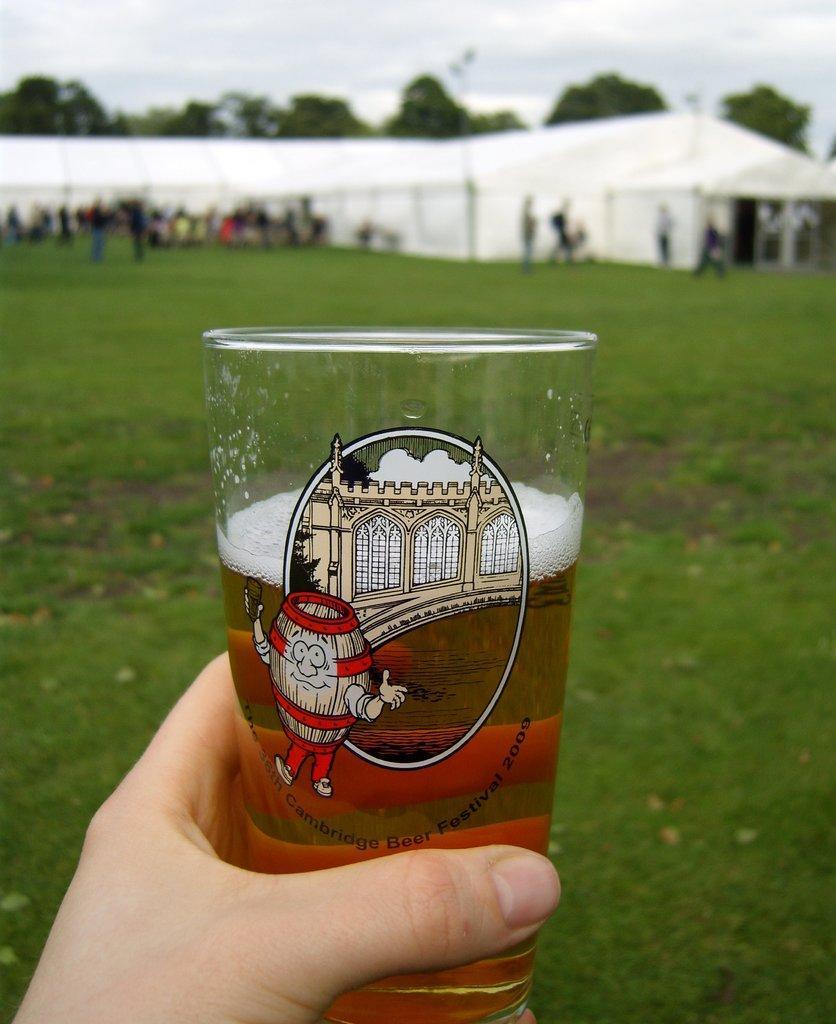In one or two sentences, can you explain what this image depicts? In this image on the foreground we can see a hand with a glass of drink. In the background there are tents, trees, people are there. The sky is cloudy. 